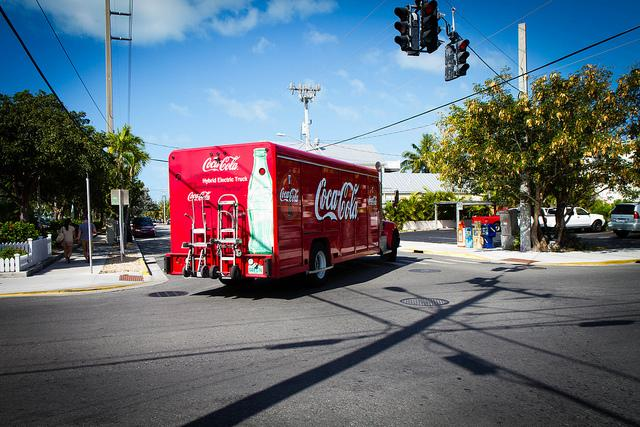Why is the truck in the middle of the street? Please explain your reasoning. turning left. The truck wants to make a turn. 